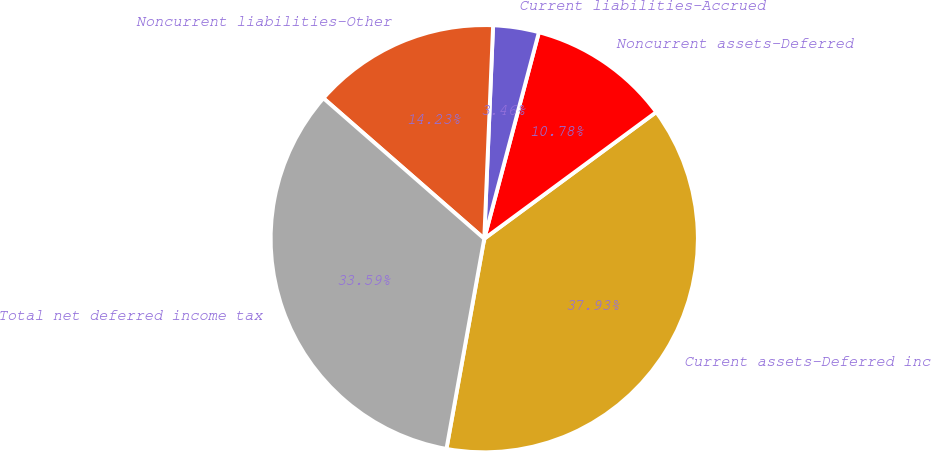<chart> <loc_0><loc_0><loc_500><loc_500><pie_chart><fcel>Current assets-Deferred income<fcel>Noncurrent assets-Deferred<fcel>Current liabilities-Accrued<fcel>Noncurrent liabilities-Other<fcel>Total net deferred income tax<nl><fcel>37.93%<fcel>10.78%<fcel>3.46%<fcel>14.23%<fcel>33.59%<nl></chart> 